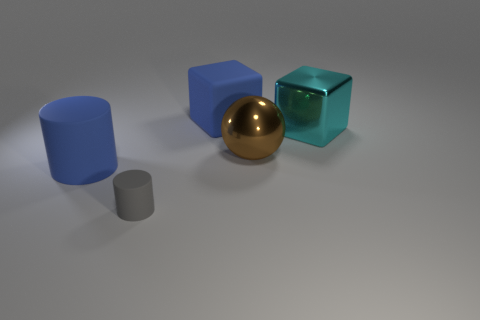Is there any other thing that has the same size as the gray rubber cylinder?
Offer a terse response. No. There is another block that is the same size as the blue cube; what is its color?
Your response must be concise. Cyan. The blue matte thing that is behind the blue object that is left of the blue object behind the big matte cylinder is what shape?
Offer a terse response. Cube. What number of cyan blocks are left of the rubber cylinder behind the gray object?
Ensure brevity in your answer.  0. Does the blue matte object that is behind the cyan shiny thing have the same shape as the object that is right of the big metal sphere?
Your answer should be very brief. Yes. There is a blue rubber block; how many tiny matte cylinders are to the right of it?
Your response must be concise. 0. Are the cyan cube that is on the right side of the brown sphere and the sphere made of the same material?
Provide a short and direct response. Yes. There is another thing that is the same shape as the large cyan thing; what is its color?
Your answer should be compact. Blue. The cyan thing has what shape?
Your answer should be compact. Cube. How many objects are big brown cylinders or large cubes?
Keep it short and to the point. 2. 